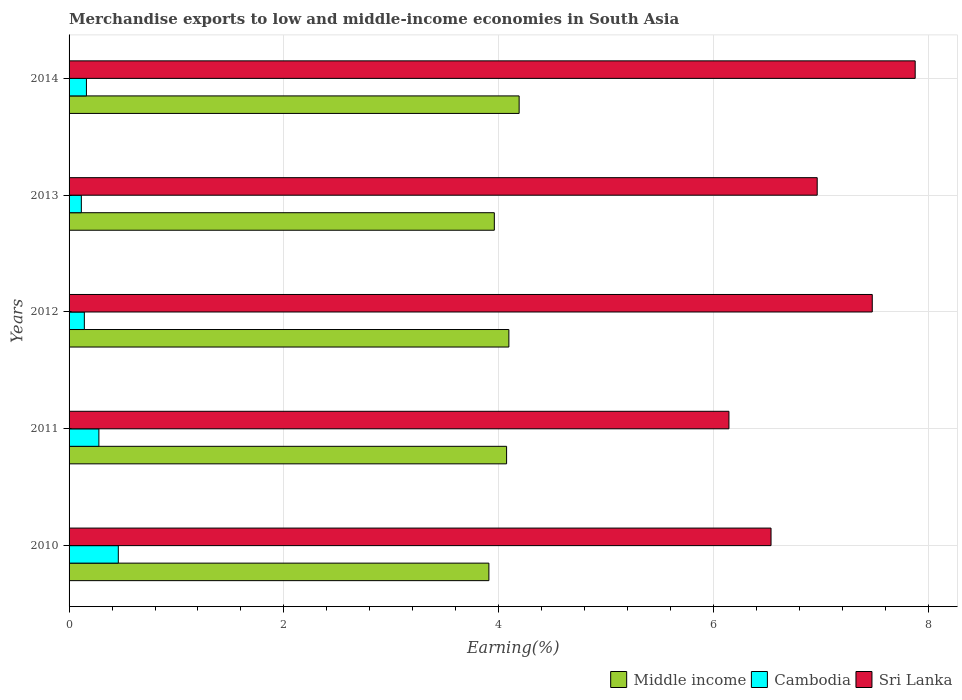How many bars are there on the 4th tick from the bottom?
Your answer should be very brief. 3. What is the label of the 5th group of bars from the top?
Your answer should be compact. 2010. What is the percentage of amount earned from merchandise exports in Middle income in 2013?
Provide a succinct answer. 3.96. Across all years, what is the maximum percentage of amount earned from merchandise exports in Cambodia?
Offer a terse response. 0.46. Across all years, what is the minimum percentage of amount earned from merchandise exports in Sri Lanka?
Your answer should be very brief. 6.14. In which year was the percentage of amount earned from merchandise exports in Cambodia minimum?
Make the answer very short. 2013. What is the total percentage of amount earned from merchandise exports in Sri Lanka in the graph?
Offer a very short reply. 35. What is the difference between the percentage of amount earned from merchandise exports in Sri Lanka in 2012 and that in 2013?
Provide a short and direct response. 0.51. What is the difference between the percentage of amount earned from merchandise exports in Sri Lanka in 2011 and the percentage of amount earned from merchandise exports in Middle income in 2012?
Provide a short and direct response. 2.05. What is the average percentage of amount earned from merchandise exports in Cambodia per year?
Your answer should be compact. 0.23. In the year 2013, what is the difference between the percentage of amount earned from merchandise exports in Cambodia and percentage of amount earned from merchandise exports in Middle income?
Your answer should be very brief. -3.85. What is the ratio of the percentage of amount earned from merchandise exports in Middle income in 2011 to that in 2014?
Make the answer very short. 0.97. Is the percentage of amount earned from merchandise exports in Sri Lanka in 2012 less than that in 2013?
Make the answer very short. No. Is the difference between the percentage of amount earned from merchandise exports in Cambodia in 2010 and 2014 greater than the difference between the percentage of amount earned from merchandise exports in Middle income in 2010 and 2014?
Provide a short and direct response. Yes. What is the difference between the highest and the second highest percentage of amount earned from merchandise exports in Cambodia?
Keep it short and to the point. 0.18. What is the difference between the highest and the lowest percentage of amount earned from merchandise exports in Sri Lanka?
Keep it short and to the point. 1.73. In how many years, is the percentage of amount earned from merchandise exports in Cambodia greater than the average percentage of amount earned from merchandise exports in Cambodia taken over all years?
Your response must be concise. 2. Is the sum of the percentage of amount earned from merchandise exports in Cambodia in 2011 and 2014 greater than the maximum percentage of amount earned from merchandise exports in Middle income across all years?
Provide a succinct answer. No. What does the 1st bar from the top in 2014 represents?
Your answer should be very brief. Sri Lanka. What does the 3rd bar from the bottom in 2011 represents?
Provide a succinct answer. Sri Lanka. Is it the case that in every year, the sum of the percentage of amount earned from merchandise exports in Middle income and percentage of amount earned from merchandise exports in Cambodia is greater than the percentage of amount earned from merchandise exports in Sri Lanka?
Your answer should be very brief. No. How many bars are there?
Offer a very short reply. 15. Are all the bars in the graph horizontal?
Your answer should be very brief. Yes. How many years are there in the graph?
Make the answer very short. 5. What is the difference between two consecutive major ticks on the X-axis?
Ensure brevity in your answer.  2. Does the graph contain grids?
Keep it short and to the point. Yes. What is the title of the graph?
Your answer should be compact. Merchandise exports to low and middle-income economies in South Asia. Does "Luxembourg" appear as one of the legend labels in the graph?
Give a very brief answer. No. What is the label or title of the X-axis?
Offer a very short reply. Earning(%). What is the label or title of the Y-axis?
Your answer should be compact. Years. What is the Earning(%) of Middle income in 2010?
Provide a short and direct response. 3.91. What is the Earning(%) in Cambodia in 2010?
Your answer should be very brief. 0.46. What is the Earning(%) of Sri Lanka in 2010?
Provide a succinct answer. 6.54. What is the Earning(%) in Middle income in 2011?
Your answer should be compact. 4.07. What is the Earning(%) of Cambodia in 2011?
Give a very brief answer. 0.28. What is the Earning(%) in Sri Lanka in 2011?
Provide a succinct answer. 6.14. What is the Earning(%) of Middle income in 2012?
Keep it short and to the point. 4.09. What is the Earning(%) in Cambodia in 2012?
Make the answer very short. 0.14. What is the Earning(%) in Sri Lanka in 2012?
Ensure brevity in your answer.  7.48. What is the Earning(%) of Middle income in 2013?
Make the answer very short. 3.96. What is the Earning(%) of Cambodia in 2013?
Ensure brevity in your answer.  0.11. What is the Earning(%) in Sri Lanka in 2013?
Provide a succinct answer. 6.97. What is the Earning(%) in Middle income in 2014?
Provide a short and direct response. 4.19. What is the Earning(%) of Cambodia in 2014?
Offer a terse response. 0.16. What is the Earning(%) in Sri Lanka in 2014?
Offer a very short reply. 7.88. Across all years, what is the maximum Earning(%) of Middle income?
Make the answer very short. 4.19. Across all years, what is the maximum Earning(%) in Cambodia?
Provide a short and direct response. 0.46. Across all years, what is the maximum Earning(%) of Sri Lanka?
Your answer should be compact. 7.88. Across all years, what is the minimum Earning(%) in Middle income?
Provide a short and direct response. 3.91. Across all years, what is the minimum Earning(%) of Cambodia?
Give a very brief answer. 0.11. Across all years, what is the minimum Earning(%) of Sri Lanka?
Your response must be concise. 6.14. What is the total Earning(%) in Middle income in the graph?
Provide a short and direct response. 20.23. What is the total Earning(%) of Cambodia in the graph?
Your answer should be compact. 1.15. What is the total Earning(%) of Sri Lanka in the graph?
Provide a short and direct response. 35. What is the difference between the Earning(%) in Middle income in 2010 and that in 2011?
Provide a short and direct response. -0.16. What is the difference between the Earning(%) of Cambodia in 2010 and that in 2011?
Ensure brevity in your answer.  0.18. What is the difference between the Earning(%) in Sri Lanka in 2010 and that in 2011?
Provide a short and direct response. 0.39. What is the difference between the Earning(%) in Middle income in 2010 and that in 2012?
Offer a terse response. -0.19. What is the difference between the Earning(%) of Cambodia in 2010 and that in 2012?
Make the answer very short. 0.32. What is the difference between the Earning(%) of Sri Lanka in 2010 and that in 2012?
Offer a very short reply. -0.94. What is the difference between the Earning(%) of Middle income in 2010 and that in 2013?
Offer a very short reply. -0.05. What is the difference between the Earning(%) in Cambodia in 2010 and that in 2013?
Provide a short and direct response. 0.34. What is the difference between the Earning(%) of Sri Lanka in 2010 and that in 2013?
Make the answer very short. -0.43. What is the difference between the Earning(%) in Middle income in 2010 and that in 2014?
Your response must be concise. -0.28. What is the difference between the Earning(%) in Cambodia in 2010 and that in 2014?
Provide a succinct answer. 0.3. What is the difference between the Earning(%) in Sri Lanka in 2010 and that in 2014?
Provide a succinct answer. -1.34. What is the difference between the Earning(%) in Middle income in 2011 and that in 2012?
Provide a short and direct response. -0.02. What is the difference between the Earning(%) in Cambodia in 2011 and that in 2012?
Offer a terse response. 0.14. What is the difference between the Earning(%) in Sri Lanka in 2011 and that in 2012?
Give a very brief answer. -1.33. What is the difference between the Earning(%) in Middle income in 2011 and that in 2013?
Make the answer very short. 0.11. What is the difference between the Earning(%) of Cambodia in 2011 and that in 2013?
Offer a very short reply. 0.16. What is the difference between the Earning(%) in Sri Lanka in 2011 and that in 2013?
Provide a short and direct response. -0.82. What is the difference between the Earning(%) of Middle income in 2011 and that in 2014?
Provide a short and direct response. -0.12. What is the difference between the Earning(%) of Cambodia in 2011 and that in 2014?
Make the answer very short. 0.12. What is the difference between the Earning(%) in Sri Lanka in 2011 and that in 2014?
Offer a terse response. -1.73. What is the difference between the Earning(%) of Middle income in 2012 and that in 2013?
Provide a succinct answer. 0.14. What is the difference between the Earning(%) of Cambodia in 2012 and that in 2013?
Your answer should be compact. 0.03. What is the difference between the Earning(%) of Sri Lanka in 2012 and that in 2013?
Your answer should be very brief. 0.51. What is the difference between the Earning(%) of Middle income in 2012 and that in 2014?
Offer a very short reply. -0.1. What is the difference between the Earning(%) of Cambodia in 2012 and that in 2014?
Offer a very short reply. -0.02. What is the difference between the Earning(%) of Sri Lanka in 2012 and that in 2014?
Give a very brief answer. -0.4. What is the difference between the Earning(%) in Middle income in 2013 and that in 2014?
Keep it short and to the point. -0.23. What is the difference between the Earning(%) in Cambodia in 2013 and that in 2014?
Make the answer very short. -0.05. What is the difference between the Earning(%) in Sri Lanka in 2013 and that in 2014?
Provide a short and direct response. -0.91. What is the difference between the Earning(%) in Middle income in 2010 and the Earning(%) in Cambodia in 2011?
Your answer should be very brief. 3.63. What is the difference between the Earning(%) of Middle income in 2010 and the Earning(%) of Sri Lanka in 2011?
Keep it short and to the point. -2.23. What is the difference between the Earning(%) in Cambodia in 2010 and the Earning(%) in Sri Lanka in 2011?
Make the answer very short. -5.69. What is the difference between the Earning(%) of Middle income in 2010 and the Earning(%) of Cambodia in 2012?
Provide a short and direct response. 3.77. What is the difference between the Earning(%) in Middle income in 2010 and the Earning(%) in Sri Lanka in 2012?
Give a very brief answer. -3.57. What is the difference between the Earning(%) of Cambodia in 2010 and the Earning(%) of Sri Lanka in 2012?
Make the answer very short. -7.02. What is the difference between the Earning(%) in Middle income in 2010 and the Earning(%) in Cambodia in 2013?
Your answer should be very brief. 3.79. What is the difference between the Earning(%) of Middle income in 2010 and the Earning(%) of Sri Lanka in 2013?
Provide a succinct answer. -3.06. What is the difference between the Earning(%) of Cambodia in 2010 and the Earning(%) of Sri Lanka in 2013?
Your answer should be compact. -6.51. What is the difference between the Earning(%) of Middle income in 2010 and the Earning(%) of Cambodia in 2014?
Give a very brief answer. 3.75. What is the difference between the Earning(%) of Middle income in 2010 and the Earning(%) of Sri Lanka in 2014?
Your answer should be very brief. -3.97. What is the difference between the Earning(%) in Cambodia in 2010 and the Earning(%) in Sri Lanka in 2014?
Keep it short and to the point. -7.42. What is the difference between the Earning(%) in Middle income in 2011 and the Earning(%) in Cambodia in 2012?
Make the answer very short. 3.93. What is the difference between the Earning(%) in Middle income in 2011 and the Earning(%) in Sri Lanka in 2012?
Provide a short and direct response. -3.4. What is the difference between the Earning(%) in Cambodia in 2011 and the Earning(%) in Sri Lanka in 2012?
Provide a short and direct response. -7.2. What is the difference between the Earning(%) in Middle income in 2011 and the Earning(%) in Cambodia in 2013?
Your response must be concise. 3.96. What is the difference between the Earning(%) in Middle income in 2011 and the Earning(%) in Sri Lanka in 2013?
Make the answer very short. -2.89. What is the difference between the Earning(%) in Cambodia in 2011 and the Earning(%) in Sri Lanka in 2013?
Make the answer very short. -6.69. What is the difference between the Earning(%) of Middle income in 2011 and the Earning(%) of Cambodia in 2014?
Ensure brevity in your answer.  3.91. What is the difference between the Earning(%) of Middle income in 2011 and the Earning(%) of Sri Lanka in 2014?
Your response must be concise. -3.8. What is the difference between the Earning(%) of Cambodia in 2011 and the Earning(%) of Sri Lanka in 2014?
Ensure brevity in your answer.  -7.6. What is the difference between the Earning(%) in Middle income in 2012 and the Earning(%) in Cambodia in 2013?
Offer a terse response. 3.98. What is the difference between the Earning(%) of Middle income in 2012 and the Earning(%) of Sri Lanka in 2013?
Provide a short and direct response. -2.87. What is the difference between the Earning(%) of Cambodia in 2012 and the Earning(%) of Sri Lanka in 2013?
Make the answer very short. -6.82. What is the difference between the Earning(%) in Middle income in 2012 and the Earning(%) in Cambodia in 2014?
Give a very brief answer. 3.93. What is the difference between the Earning(%) in Middle income in 2012 and the Earning(%) in Sri Lanka in 2014?
Ensure brevity in your answer.  -3.78. What is the difference between the Earning(%) of Cambodia in 2012 and the Earning(%) of Sri Lanka in 2014?
Make the answer very short. -7.74. What is the difference between the Earning(%) of Middle income in 2013 and the Earning(%) of Cambodia in 2014?
Offer a very short reply. 3.8. What is the difference between the Earning(%) in Middle income in 2013 and the Earning(%) in Sri Lanka in 2014?
Make the answer very short. -3.92. What is the difference between the Earning(%) in Cambodia in 2013 and the Earning(%) in Sri Lanka in 2014?
Provide a succinct answer. -7.76. What is the average Earning(%) of Middle income per year?
Give a very brief answer. 4.05. What is the average Earning(%) of Cambodia per year?
Ensure brevity in your answer.  0.23. What is the average Earning(%) in Sri Lanka per year?
Your answer should be compact. 7. In the year 2010, what is the difference between the Earning(%) in Middle income and Earning(%) in Cambodia?
Your response must be concise. 3.45. In the year 2010, what is the difference between the Earning(%) in Middle income and Earning(%) in Sri Lanka?
Offer a terse response. -2.63. In the year 2010, what is the difference between the Earning(%) in Cambodia and Earning(%) in Sri Lanka?
Ensure brevity in your answer.  -6.08. In the year 2011, what is the difference between the Earning(%) of Middle income and Earning(%) of Cambodia?
Make the answer very short. 3.8. In the year 2011, what is the difference between the Earning(%) in Middle income and Earning(%) in Sri Lanka?
Your answer should be very brief. -2.07. In the year 2011, what is the difference between the Earning(%) in Cambodia and Earning(%) in Sri Lanka?
Offer a very short reply. -5.87. In the year 2012, what is the difference between the Earning(%) of Middle income and Earning(%) of Cambodia?
Offer a terse response. 3.95. In the year 2012, what is the difference between the Earning(%) in Middle income and Earning(%) in Sri Lanka?
Make the answer very short. -3.38. In the year 2012, what is the difference between the Earning(%) in Cambodia and Earning(%) in Sri Lanka?
Provide a short and direct response. -7.34. In the year 2013, what is the difference between the Earning(%) in Middle income and Earning(%) in Cambodia?
Provide a succinct answer. 3.85. In the year 2013, what is the difference between the Earning(%) of Middle income and Earning(%) of Sri Lanka?
Offer a very short reply. -3.01. In the year 2013, what is the difference between the Earning(%) of Cambodia and Earning(%) of Sri Lanka?
Offer a very short reply. -6.85. In the year 2014, what is the difference between the Earning(%) in Middle income and Earning(%) in Cambodia?
Offer a very short reply. 4.03. In the year 2014, what is the difference between the Earning(%) in Middle income and Earning(%) in Sri Lanka?
Offer a terse response. -3.69. In the year 2014, what is the difference between the Earning(%) of Cambodia and Earning(%) of Sri Lanka?
Offer a very short reply. -7.72. What is the ratio of the Earning(%) in Middle income in 2010 to that in 2011?
Ensure brevity in your answer.  0.96. What is the ratio of the Earning(%) in Cambodia in 2010 to that in 2011?
Keep it short and to the point. 1.65. What is the ratio of the Earning(%) in Sri Lanka in 2010 to that in 2011?
Make the answer very short. 1.06. What is the ratio of the Earning(%) of Middle income in 2010 to that in 2012?
Keep it short and to the point. 0.95. What is the ratio of the Earning(%) of Cambodia in 2010 to that in 2012?
Offer a terse response. 3.22. What is the ratio of the Earning(%) in Sri Lanka in 2010 to that in 2012?
Keep it short and to the point. 0.87. What is the ratio of the Earning(%) of Middle income in 2010 to that in 2013?
Provide a succinct answer. 0.99. What is the ratio of the Earning(%) of Cambodia in 2010 to that in 2013?
Offer a terse response. 4.01. What is the ratio of the Earning(%) of Sri Lanka in 2010 to that in 2013?
Ensure brevity in your answer.  0.94. What is the ratio of the Earning(%) in Middle income in 2010 to that in 2014?
Make the answer very short. 0.93. What is the ratio of the Earning(%) in Cambodia in 2010 to that in 2014?
Ensure brevity in your answer.  2.83. What is the ratio of the Earning(%) of Sri Lanka in 2010 to that in 2014?
Give a very brief answer. 0.83. What is the ratio of the Earning(%) of Middle income in 2011 to that in 2012?
Offer a terse response. 0.99. What is the ratio of the Earning(%) of Cambodia in 2011 to that in 2012?
Offer a terse response. 1.95. What is the ratio of the Earning(%) of Sri Lanka in 2011 to that in 2012?
Offer a terse response. 0.82. What is the ratio of the Earning(%) in Middle income in 2011 to that in 2013?
Offer a very short reply. 1.03. What is the ratio of the Earning(%) in Cambodia in 2011 to that in 2013?
Provide a succinct answer. 2.43. What is the ratio of the Earning(%) in Sri Lanka in 2011 to that in 2013?
Provide a succinct answer. 0.88. What is the ratio of the Earning(%) in Middle income in 2011 to that in 2014?
Ensure brevity in your answer.  0.97. What is the ratio of the Earning(%) in Cambodia in 2011 to that in 2014?
Offer a terse response. 1.72. What is the ratio of the Earning(%) of Sri Lanka in 2011 to that in 2014?
Your answer should be very brief. 0.78. What is the ratio of the Earning(%) in Middle income in 2012 to that in 2013?
Your response must be concise. 1.03. What is the ratio of the Earning(%) of Cambodia in 2012 to that in 2013?
Your answer should be very brief. 1.24. What is the ratio of the Earning(%) in Sri Lanka in 2012 to that in 2013?
Give a very brief answer. 1.07. What is the ratio of the Earning(%) in Middle income in 2012 to that in 2014?
Your answer should be very brief. 0.98. What is the ratio of the Earning(%) in Cambodia in 2012 to that in 2014?
Keep it short and to the point. 0.88. What is the ratio of the Earning(%) in Sri Lanka in 2012 to that in 2014?
Provide a succinct answer. 0.95. What is the ratio of the Earning(%) in Middle income in 2013 to that in 2014?
Provide a succinct answer. 0.94. What is the ratio of the Earning(%) of Cambodia in 2013 to that in 2014?
Your response must be concise. 0.71. What is the ratio of the Earning(%) of Sri Lanka in 2013 to that in 2014?
Your response must be concise. 0.88. What is the difference between the highest and the second highest Earning(%) in Middle income?
Your answer should be very brief. 0.1. What is the difference between the highest and the second highest Earning(%) in Cambodia?
Ensure brevity in your answer.  0.18. What is the difference between the highest and the second highest Earning(%) of Sri Lanka?
Your answer should be very brief. 0.4. What is the difference between the highest and the lowest Earning(%) in Middle income?
Provide a short and direct response. 0.28. What is the difference between the highest and the lowest Earning(%) in Cambodia?
Your response must be concise. 0.34. What is the difference between the highest and the lowest Earning(%) of Sri Lanka?
Your answer should be compact. 1.73. 